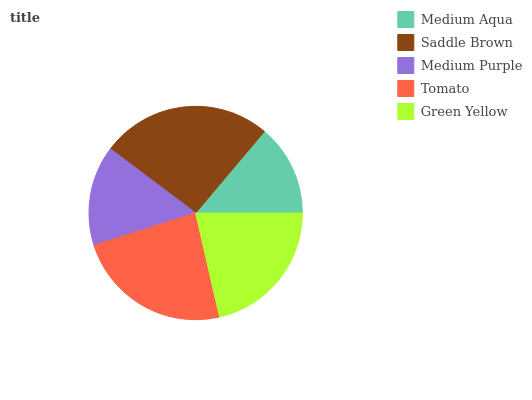Is Medium Aqua the minimum?
Answer yes or no. Yes. Is Saddle Brown the maximum?
Answer yes or no. Yes. Is Medium Purple the minimum?
Answer yes or no. No. Is Medium Purple the maximum?
Answer yes or no. No. Is Saddle Brown greater than Medium Purple?
Answer yes or no. Yes. Is Medium Purple less than Saddle Brown?
Answer yes or no. Yes. Is Medium Purple greater than Saddle Brown?
Answer yes or no. No. Is Saddle Brown less than Medium Purple?
Answer yes or no. No. Is Green Yellow the high median?
Answer yes or no. Yes. Is Green Yellow the low median?
Answer yes or no. Yes. Is Medium Aqua the high median?
Answer yes or no. No. Is Medium Aqua the low median?
Answer yes or no. No. 